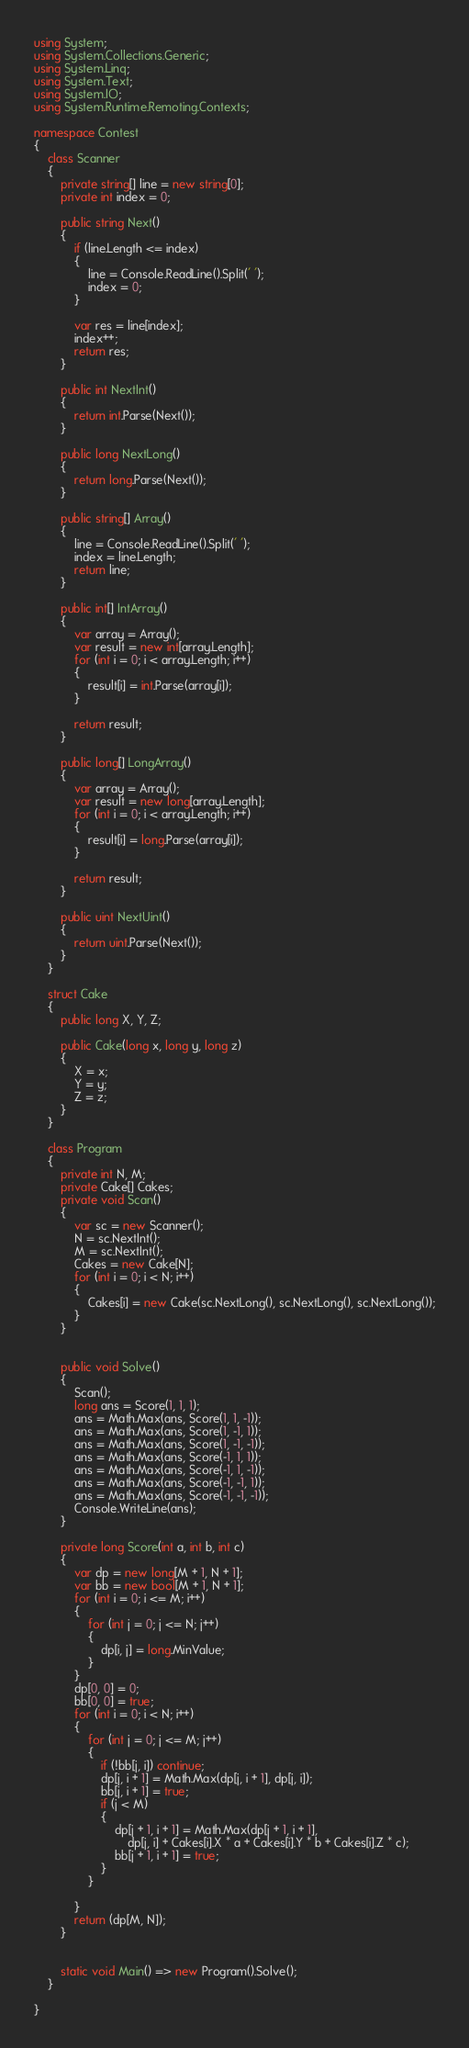Convert code to text. <code><loc_0><loc_0><loc_500><loc_500><_C#_>using System;
using System.Collections.Generic;
using System.Linq;
using System.Text;
using System.IO;
using System.Runtime.Remoting.Contexts;

namespace Contest
{
    class Scanner
    {
        private string[] line = new string[0];
        private int index = 0;

        public string Next()
        {
            if (line.Length <= index)
            {
                line = Console.ReadLine().Split(' ');
                index = 0;
            }

            var res = line[index];
            index++;
            return res;
        }

        public int NextInt()
        {
            return int.Parse(Next());
        }

        public long NextLong()
        {
            return long.Parse(Next());
        }

        public string[] Array()
        {
            line = Console.ReadLine().Split(' ');
            index = line.Length;
            return line;
        }

        public int[] IntArray()
        {
            var array = Array();
            var result = new int[array.Length];
            for (int i = 0; i < array.Length; i++)
            {
                result[i] = int.Parse(array[i]);
            }

            return result;
        }

        public long[] LongArray()
        {
            var array = Array();
            var result = new long[array.Length];
            for (int i = 0; i < array.Length; i++)
            {
                result[i] = long.Parse(array[i]);
            }

            return result;
        }

        public uint NextUint()
        {
            return uint.Parse(Next());
        }
    }

    struct Cake
    {
        public long X, Y, Z;

        public Cake(long x, long y, long z)
        {
            X = x;
            Y = y;
            Z = z;
        }
    }

    class Program
    {
        private int N, M;
        private Cake[] Cakes;
        private void Scan()
        {
            var sc = new Scanner();
            N = sc.NextInt();
            M = sc.NextInt();
            Cakes = new Cake[N];
            for (int i = 0; i < N; i++)
            {
                Cakes[i] = new Cake(sc.NextLong(), sc.NextLong(), sc.NextLong());
            }
        }


        public void Solve()
        {
            Scan();
            long ans = Score(1, 1, 1);
            ans = Math.Max(ans, Score(1, 1, -1));
            ans = Math.Max(ans, Score(1, -1, 1));
            ans = Math.Max(ans, Score(1, -1, -1));
            ans = Math.Max(ans, Score(-1, 1, 1));
            ans = Math.Max(ans, Score(-1, 1, -1));
            ans = Math.Max(ans, Score(-1, -1, 1));
            ans = Math.Max(ans, Score(-1, -1, -1));
            Console.WriteLine(ans);
        }

        private long Score(int a, int b, int c)
        {
            var dp = new long[M + 1, N + 1];
            var bb = new bool[M + 1, N + 1];
            for (int i = 0; i <= M; i++)
            {
                for (int j = 0; j <= N; j++)
                {
                    dp[i, j] = long.MinValue;
                }
            }
            dp[0, 0] = 0;
            bb[0, 0] = true;
            for (int i = 0; i < N; i++)
            {
                for (int j = 0; j <= M; j++)
                {
                    if (!bb[j, i]) continue;
                    dp[j, i + 1] = Math.Max(dp[j, i + 1], dp[j, i]);
                    bb[j, i + 1] = true;
                    if (j < M)
                    {
                        dp[j + 1, i + 1] = Math.Max(dp[j + 1, i + 1],
                            dp[j, i] + Cakes[i].X * a + Cakes[i].Y * b + Cakes[i].Z * c);
                        bb[j + 1, i + 1] = true;
                    }
                }

            }
            return (dp[M, N]);
        }


        static void Main() => new Program().Solve();
    }

}
</code> 